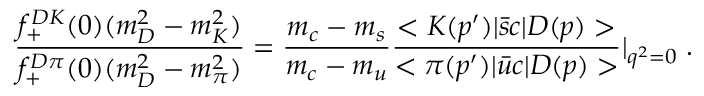<formula> <loc_0><loc_0><loc_500><loc_500>\frac { f _ { + } ^ { D K } ( 0 ) ( m _ { D } ^ { 2 } - m _ { K } ^ { 2 } ) } { f _ { + } ^ { D \pi } ( 0 ) ( m _ { D } ^ { 2 } - m _ { \pi } ^ { 2 } ) } = \frac { m _ { c } - m _ { s } } { m _ { c } - m _ { u } } \frac { < K ( p ^ { \prime } ) | { \bar { s } } c | D ( p ) > } { < \pi ( p ^ { \prime } ) | { \bar { u } } c | D ( p ) > } | _ { q ^ { 2 } = 0 } \, .</formula> 